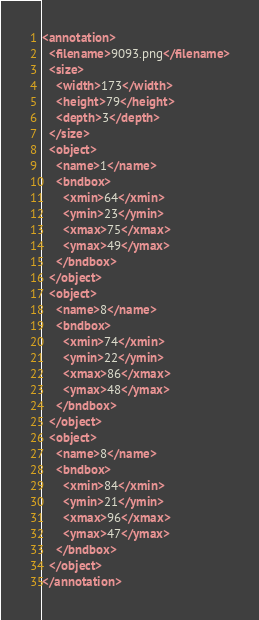<code> <loc_0><loc_0><loc_500><loc_500><_XML_><annotation>
  <filename>9093.png</filename>
  <size>
    <width>173</width>
    <height>79</height>
    <depth>3</depth>
  </size>
  <object>
    <name>1</name>
    <bndbox>
      <xmin>64</xmin>
      <ymin>23</ymin>
      <xmax>75</xmax>
      <ymax>49</ymax>
    </bndbox>
  </object>
  <object>
    <name>8</name>
    <bndbox>
      <xmin>74</xmin>
      <ymin>22</ymin>
      <xmax>86</xmax>
      <ymax>48</ymax>
    </bndbox>
  </object>
  <object>
    <name>8</name>
    <bndbox>
      <xmin>84</xmin>
      <ymin>21</ymin>
      <xmax>96</xmax>
      <ymax>47</ymax>
    </bndbox>
  </object>
</annotation>
</code> 